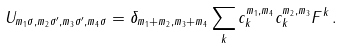Convert formula to latex. <formula><loc_0><loc_0><loc_500><loc_500>U _ { { m _ { 1 } } { \sigma } , { m _ { 2 } } { \sigma } ^ { \prime } , { m _ { 3 } } { \sigma } ^ { \prime } , { m _ { 4 } } { \sigma } } = { \delta } _ { { m _ { 1 } } + { m _ { 2 } } , { m _ { 3 } } + { m _ { 4 } } } \sum _ { k } c _ { k } ^ { { m _ { 1 } } , { m _ { 4 } } } c _ { k } ^ { { m _ { 2 } } , { m _ { 3 } } } F ^ { k } \, .</formula> 